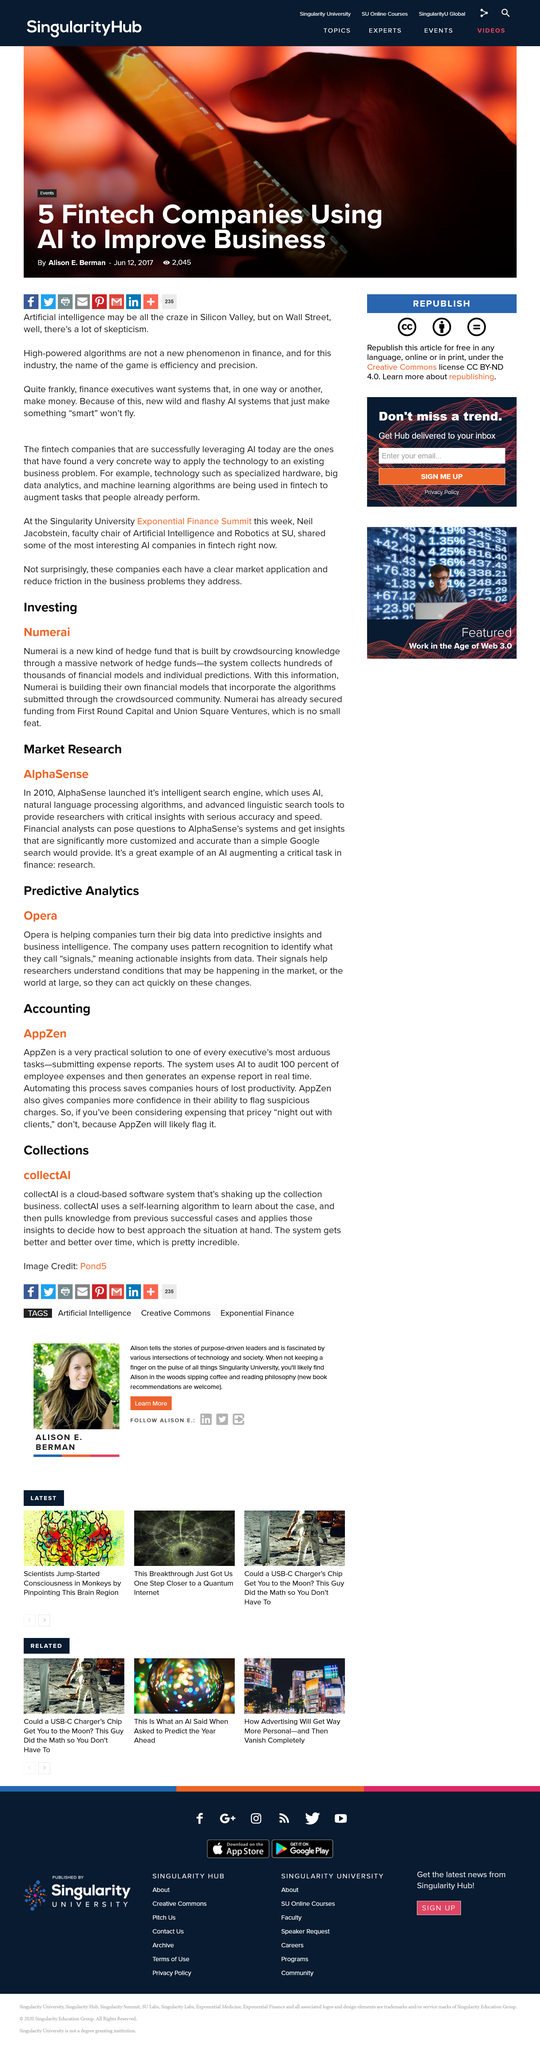Outline some significant characteristics in this image. AppZen can assist with accounting within various departments. Automating this process is a good idea because it saves time. The article identifies research as a critical task in finance. AlphaSense, a company that has launched an intelligent search engine that utilizes AI, has introduced a new and innovative way to search for information. The intelligent search engine launched by the company in the year 2010. 